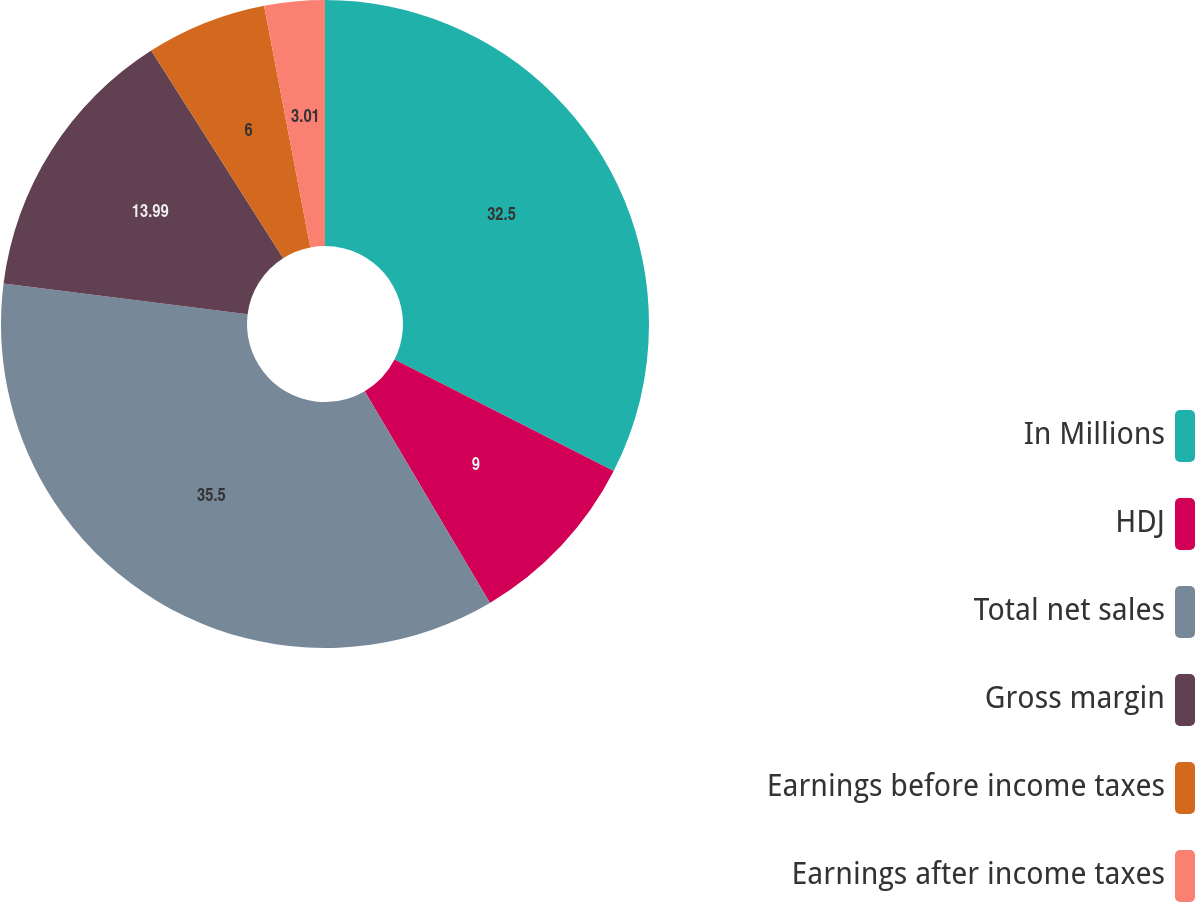Convert chart. <chart><loc_0><loc_0><loc_500><loc_500><pie_chart><fcel>In Millions<fcel>HDJ<fcel>Total net sales<fcel>Gross margin<fcel>Earnings before income taxes<fcel>Earnings after income taxes<nl><fcel>32.5%<fcel>9.0%<fcel>35.5%<fcel>13.99%<fcel>6.0%<fcel>3.01%<nl></chart> 